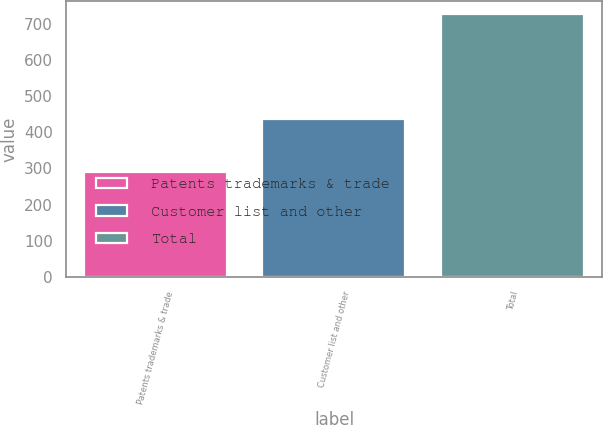<chart> <loc_0><loc_0><loc_500><loc_500><bar_chart><fcel>Patents trademarks & trade<fcel>Customer list and other<fcel>Total<nl><fcel>290<fcel>436<fcel>726<nl></chart> 